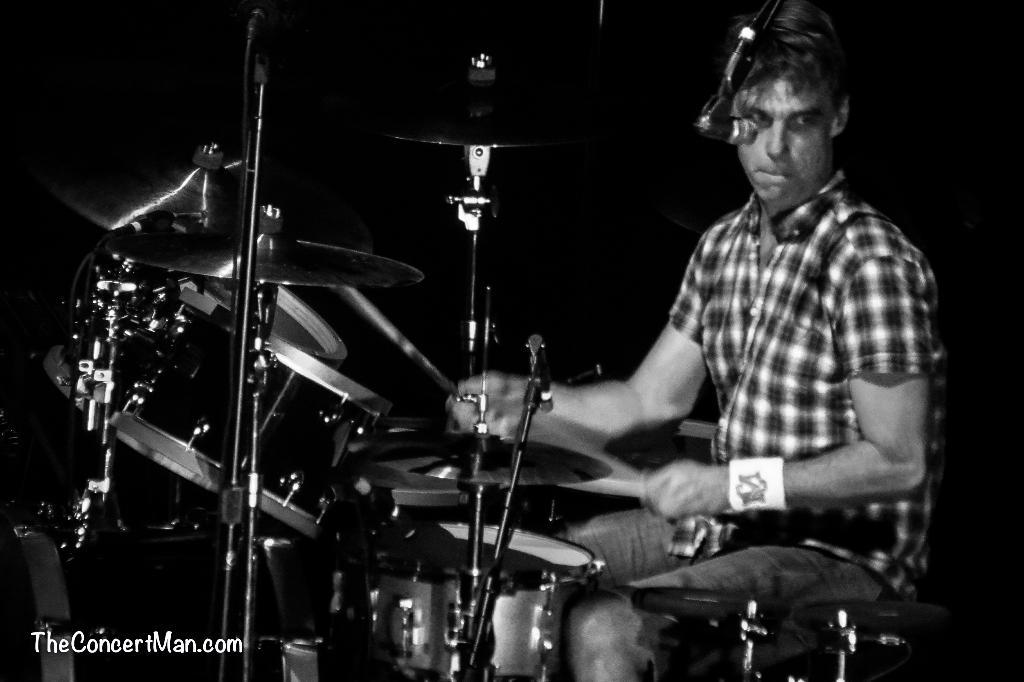What is the color scheme of the image? The image is black and white. What is the person in the image doing? The person is playing musical instruments. Where is the text located in the image? The text is in the bottom left corner of the image. Can you see the person's tail in the image? There is no tail visible in the image, as it features a person playing musical instruments. What type of cake is being served in the image? There is no cake present in the image. 